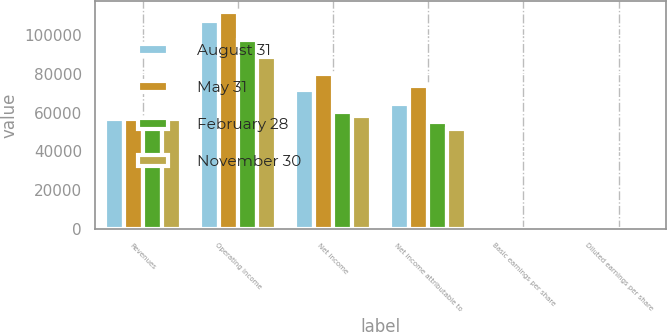<chart> <loc_0><loc_0><loc_500><loc_500><stacked_bar_chart><ecel><fcel>Revenues<fcel>Operating income<fcel>Net income<fcel>Net income attributable to<fcel>Basic earnings per share<fcel>Diluted earnings per share<nl><fcel>August 31<fcel>56693.5<fcel>107384<fcel>71708<fcel>64643<fcel>0.88<fcel>0.87<nl><fcel>May 31<fcel>56693.5<fcel>111907<fcel>79857<fcel>73897<fcel>1.02<fcel>1.02<nl><fcel>February 28<fcel>56693.5<fcel>97291<fcel>60121<fcel>55121<fcel>0.77<fcel>0.76<nl><fcel>November 30<fcel>56693.5<fcel>88917<fcel>58266<fcel>51625<fcel>0.73<fcel>0.72<nl></chart> 